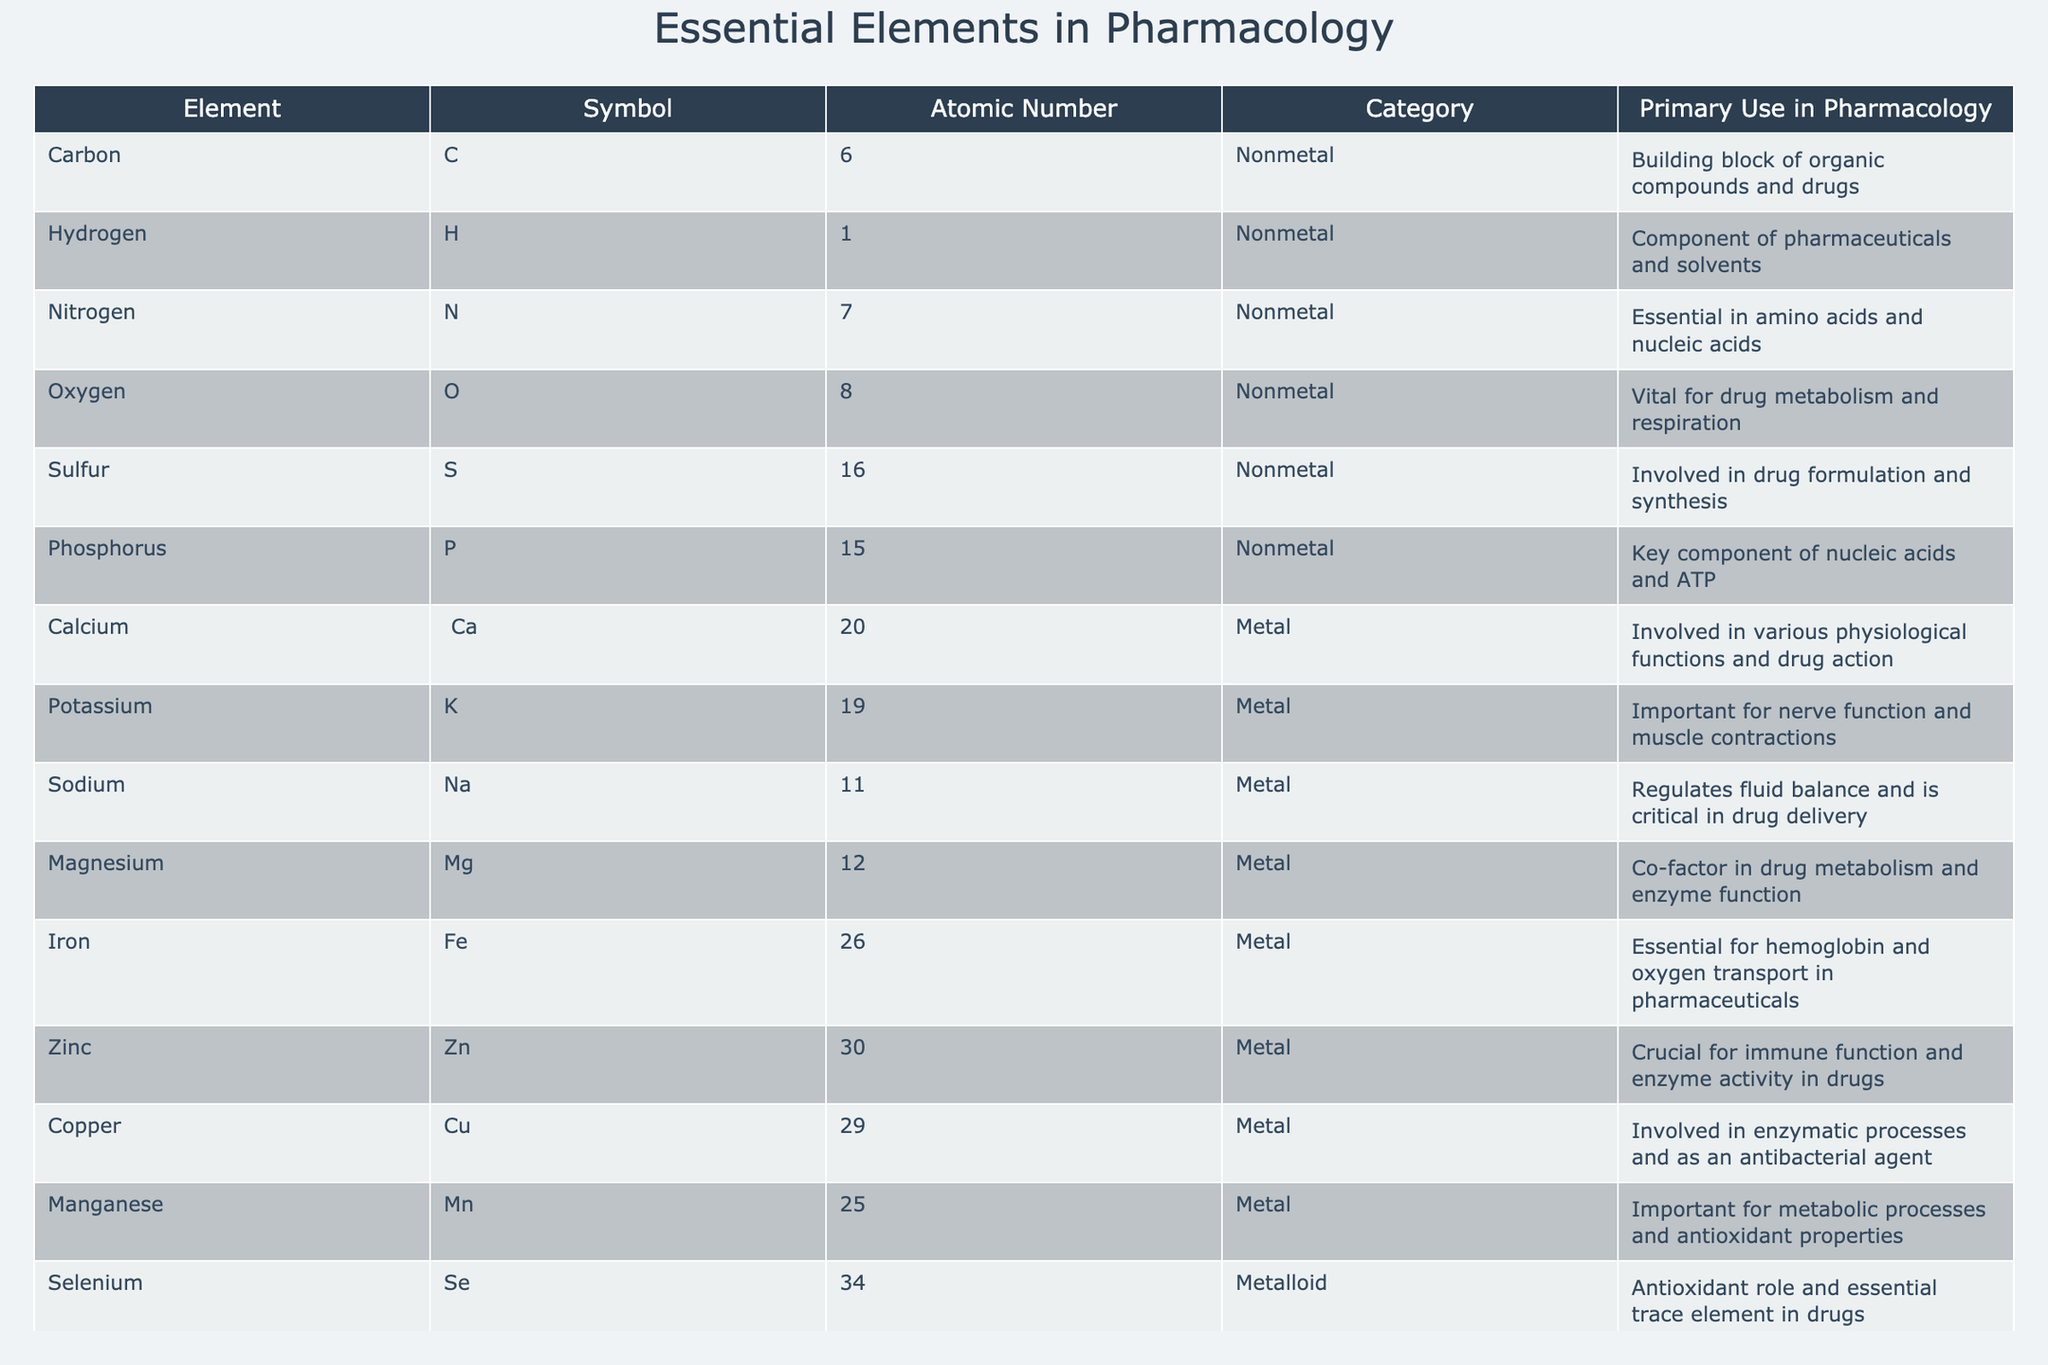What is the atomic number of Sodium? Sodium is represented by the symbol Na and is listed in the table with its corresponding atomic number in the third column, which shows that Sodium has an atomic number of 11.
Answer: 11 Which element is essential for thyroid hormone production? The table indicates that Iodine, listed under the Element column, is essential for thyroid hormone production according to its primary use in pharmacology.
Answer: Iodine Does Calcium belong to the metal category? By checking the category column, we find that Calcium, represented as Ca, is classified as a Metal. This confirms that the statement is true.
Answer: Yes Which elements are involved in drug metabolism? The table lists multiple elements, including Oxygen, Magnesium, and Zinc, which are mentioned in their primary use as being involved in drug metabolism and enzyme function.
Answer: Oxygen, Magnesium, Zinc What is the total number of nonmetals and metals listed in the table? Counting from the category column, we find 8 nonmetals and 7 metals, which can be summed up to provide the total. Thus, adding them gives 8 + 7 = 15.
Answer: 15 Which element has the highest atomic number? Reviewing the atomic number values in the table, we see that Iodine has the highest atomic number of 53 among the listed elements.
Answer: Iodine Is Sulfur involved in drug formulation? In the primary use column, Sulfur is noted for its involvement in drug formulation and synthesis, confirming that the statement is true.
Answer: Yes What is the primary use of Phosphorus in pharmacology? Checking the primary use of Phosphorus in the table, it is identified as a key component of nucleic acids and ATP, indicating its importance in pharmacology.
Answer: Key component of nucleic acids and ATP List all elements that share the same usage in pharmacology as Iron. Iron is primarily used for hemoglobin and oxygen transport in pharmaceuticals. Referring to the table, Managanese also shows antioxidant properties, indicating a similar importance but differing in specific function. Thus, only Iron fits in this usage.
Answer: Iron How many elements are crucial for immune function? The table indicates that only Zinc is specifically noted for its crucial role in immune function, leading to the conclusion that it is the only one listed for this purpose.
Answer: 1 